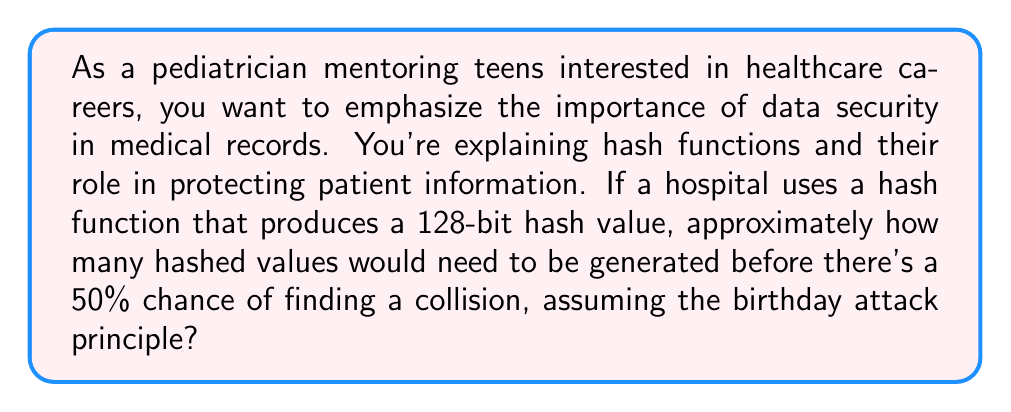Solve this math problem. To solve this problem, we'll use the birthday attack principle and the following steps:

1) The birthday attack is based on the birthday paradox, which states that in a group of 23 people, there's about a 50% chance that two people share the same birthday.

2) For hash functions, we use a similar principle. The probability of a collision reaches about 50% when the number of hashes is approximately the square root of the total possible hash values.

3) For a 128-bit hash, the total number of possible hash values is $2^{128}$.

4) To find the number of hashes needed for a 50% chance of collision, we calculate:

   $$\sqrt{2^{128}} = 2^{64}$$

5) However, this is an approximation. For a more precise calculation, we can use the formula:

   $$n \approx \sqrt{2 \ln(2) \cdot 2^{128}}$$

6) Calculating this:
   
   $$n \approx \sqrt{2 \ln(2) \cdot 2^{128}} \approx 1.18 \times 2^{64}$$

7) This is approximately $2.17 \times 10^{19}$ hashed values.

In a healthcare context, this demonstrates the strength of 128-bit hash functions in protecting patient data, as generating this many hashes would be computationally infeasible for attackers.
Answer: $2.17 \times 10^{19}$ hashed values 